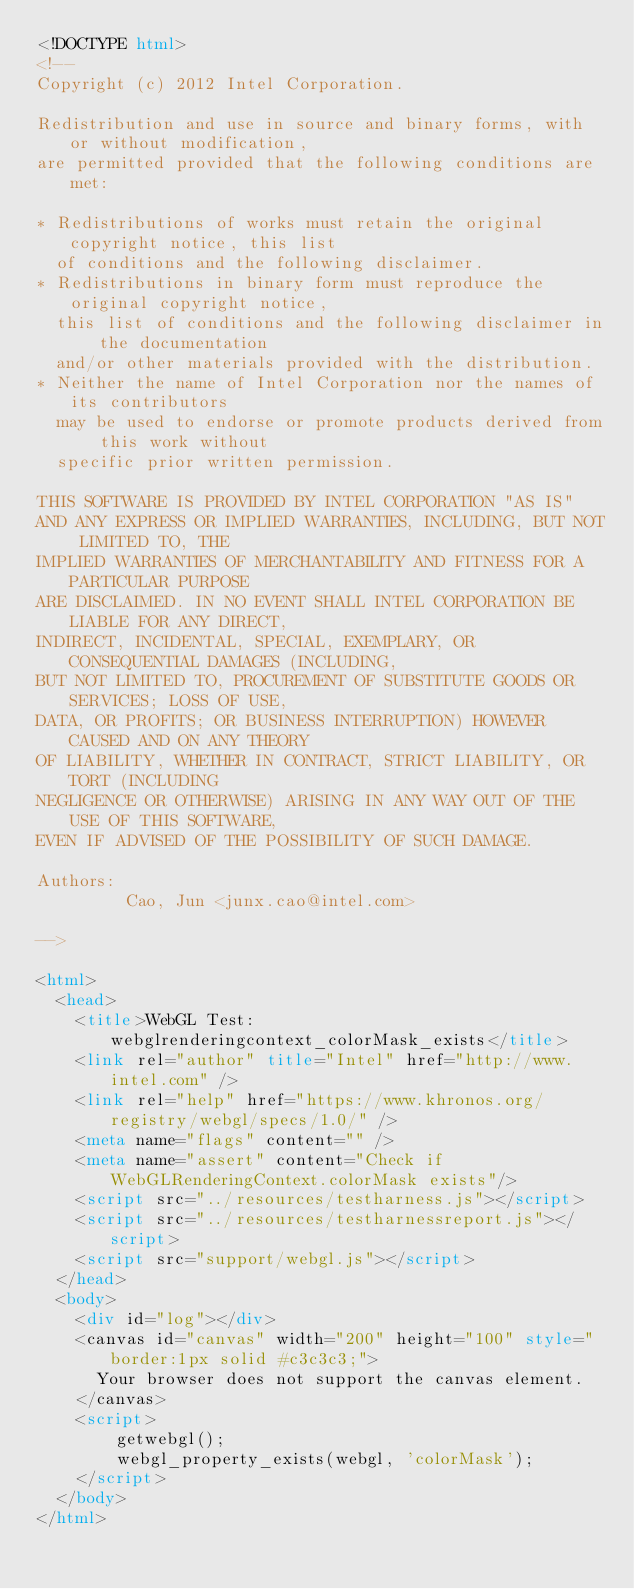<code> <loc_0><loc_0><loc_500><loc_500><_HTML_><!DOCTYPE html>
<!--
Copyright (c) 2012 Intel Corporation.

Redistribution and use in source and binary forms, with or without modification,
are permitted provided that the following conditions are met:

* Redistributions of works must retain the original copyright notice, this list
  of conditions and the following disclaimer.
* Redistributions in binary form must reproduce the original copyright notice,
  this list of conditions and the following disclaimer in the documentation
  and/or other materials provided with the distribution.
* Neither the name of Intel Corporation nor the names of its contributors
  may be used to endorse or promote products derived from this work without
  specific prior written permission.

THIS SOFTWARE IS PROVIDED BY INTEL CORPORATION "AS IS"
AND ANY EXPRESS OR IMPLIED WARRANTIES, INCLUDING, BUT NOT LIMITED TO, THE
IMPLIED WARRANTIES OF MERCHANTABILITY AND FITNESS FOR A PARTICULAR PURPOSE
ARE DISCLAIMED. IN NO EVENT SHALL INTEL CORPORATION BE LIABLE FOR ANY DIRECT,
INDIRECT, INCIDENTAL, SPECIAL, EXEMPLARY, OR CONSEQUENTIAL DAMAGES (INCLUDING,
BUT NOT LIMITED TO, PROCUREMENT OF SUBSTITUTE GOODS OR SERVICES; LOSS OF USE,
DATA, OR PROFITS; OR BUSINESS INTERRUPTION) HOWEVER CAUSED AND ON ANY THEORY
OF LIABILITY, WHETHER IN CONTRACT, STRICT LIABILITY, OR TORT (INCLUDING
NEGLIGENCE OR OTHERWISE) ARISING IN ANY WAY OUT OF THE USE OF THIS SOFTWARE,
EVEN IF ADVISED OF THE POSSIBILITY OF SUCH DAMAGE.

Authors:
         Cao, Jun <junx.cao@intel.com>

-->

<html>
  <head>
    <title>WebGL Test: webglrenderingcontext_colorMask_exists</title>
    <link rel="author" title="Intel" href="http://www.intel.com" />
    <link rel="help" href="https://www.khronos.org/registry/webgl/specs/1.0/" />
    <meta name="flags" content="" />
    <meta name="assert" content="Check if WebGLRenderingContext.colorMask exists"/>
    <script src="../resources/testharness.js"></script>
    <script src="../resources/testharnessreport.js"></script>
    <script src="support/webgl.js"></script>
  </head>
  <body>
    <div id="log"></div>
    <canvas id="canvas" width="200" height="100" style="border:1px solid #c3c3c3;">
      Your browser does not support the canvas element.
    </canvas>
    <script>
        getwebgl();
        webgl_property_exists(webgl, 'colorMask');
    </script>
  </body>
</html>
</code> 